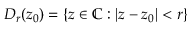<formula> <loc_0><loc_0><loc_500><loc_500>D _ { r } ( z _ { 0 } ) = \{ z \in \mathbb { C } \colon | z - z _ { 0 } | < r \}</formula> 